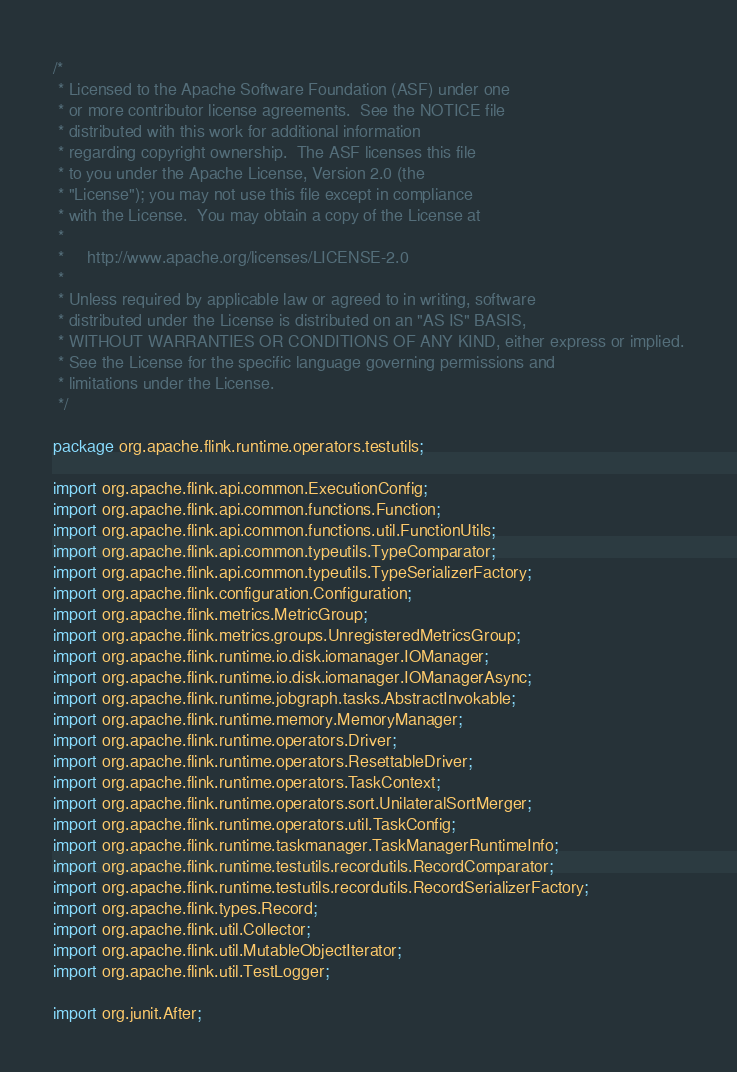<code> <loc_0><loc_0><loc_500><loc_500><_Java_>/*
 * Licensed to the Apache Software Foundation (ASF) under one
 * or more contributor license agreements.  See the NOTICE file
 * distributed with this work for additional information
 * regarding copyright ownership.  The ASF licenses this file
 * to you under the Apache License, Version 2.0 (the
 * "License"); you may not use this file except in compliance
 * with the License.  You may obtain a copy of the License at
 *
 *     http://www.apache.org/licenses/LICENSE-2.0
 *
 * Unless required by applicable law or agreed to in writing, software
 * distributed under the License is distributed on an "AS IS" BASIS,
 * WITHOUT WARRANTIES OR CONDITIONS OF ANY KIND, either express or implied.
 * See the License for the specific language governing permissions and
 * limitations under the License.
 */

package org.apache.flink.runtime.operators.testutils;

import org.apache.flink.api.common.ExecutionConfig;
import org.apache.flink.api.common.functions.Function;
import org.apache.flink.api.common.functions.util.FunctionUtils;
import org.apache.flink.api.common.typeutils.TypeComparator;
import org.apache.flink.api.common.typeutils.TypeSerializerFactory;
import org.apache.flink.configuration.Configuration;
import org.apache.flink.metrics.MetricGroup;
import org.apache.flink.metrics.groups.UnregisteredMetricsGroup;
import org.apache.flink.runtime.io.disk.iomanager.IOManager;
import org.apache.flink.runtime.io.disk.iomanager.IOManagerAsync;
import org.apache.flink.runtime.jobgraph.tasks.AbstractInvokable;
import org.apache.flink.runtime.memory.MemoryManager;
import org.apache.flink.runtime.operators.Driver;
import org.apache.flink.runtime.operators.ResettableDriver;
import org.apache.flink.runtime.operators.TaskContext;
import org.apache.flink.runtime.operators.sort.UnilateralSortMerger;
import org.apache.flink.runtime.operators.util.TaskConfig;
import org.apache.flink.runtime.taskmanager.TaskManagerRuntimeInfo;
import org.apache.flink.runtime.testutils.recordutils.RecordComparator;
import org.apache.flink.runtime.testutils.recordutils.RecordSerializerFactory;
import org.apache.flink.types.Record;
import org.apache.flink.util.Collector;
import org.apache.flink.util.MutableObjectIterator;
import org.apache.flink.util.TestLogger;

import org.junit.After;</code> 